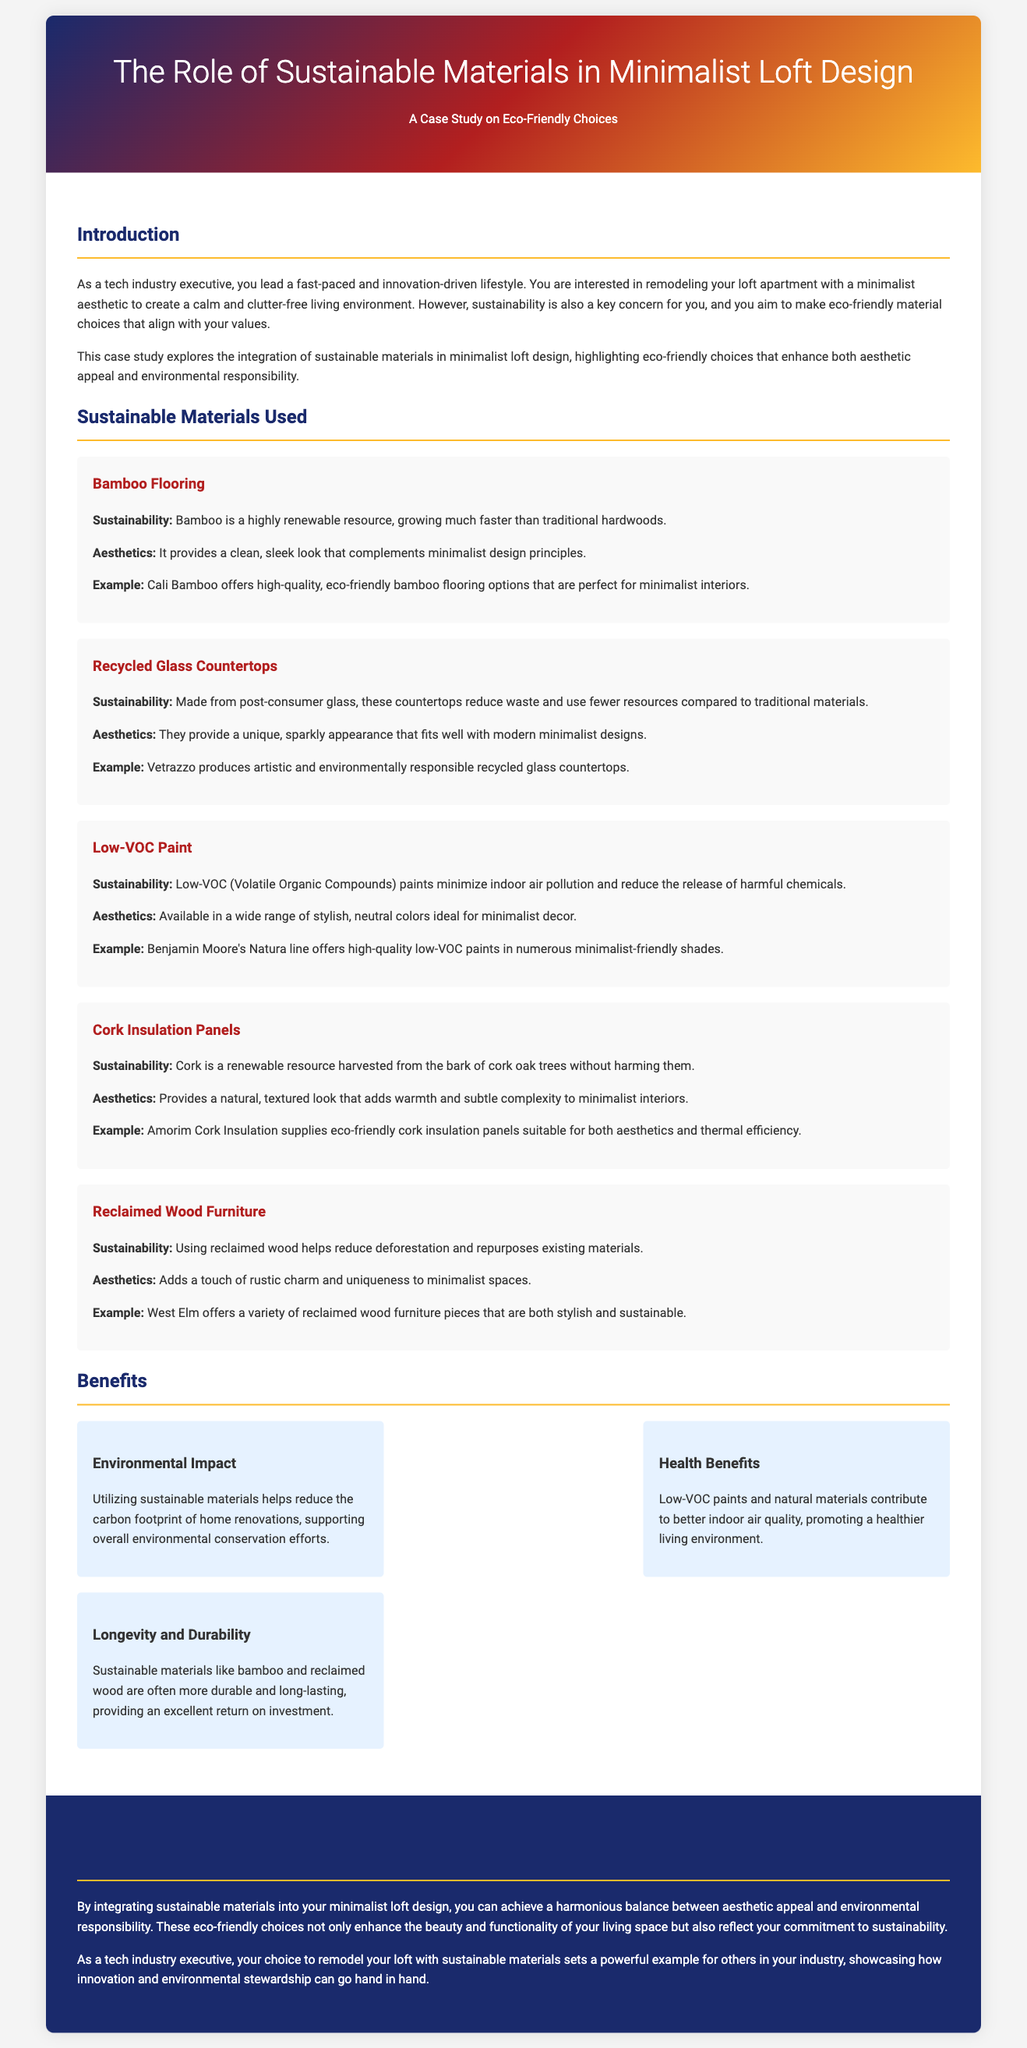What is the title of the case study? The title of the case study is explicitly stated in the document.
Answer: The Role of Sustainable Materials in Minimalist Loft Design What type of flooring is highlighted as eco-friendly? The document mentions various sustainable materials, one of which is specified as flooring.
Answer: Bamboo Flooring What are recycled glass countertops made from? The document explicitly states the composition of the recycled glass countertops.
Answer: Post-consumer glass Which line of paint is mentioned for its low-VOC quality? The document provides an example of a paint line that is low in volatile organic compounds.
Answer: Benjamin Moore's Natura line What is a benefit of using low-VOC paints? The document outlines the advantages of low-VOC paints in relation to air quality.
Answer: Better indoor air quality Which material provides insulation and is renewable? The document specifies a material that is used for insulation and is highlighted as a renewable resource.
Answer: Cork How does using sustainable materials impact the carbon footprint? The document addresses the effect of sustainable materials on environmental conservation efforts.
Answer: Helps reduce the carbon footprint What aesthetic quality does reclaimed wood furniture add? The document mentions the visual appeal contributed by a specific type of furniture.
Answer: Rustic charm 